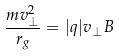Convert formula to latex. <formula><loc_0><loc_0><loc_500><loc_500>\frac { m v _ { \perp } ^ { 2 } } { r _ { g } } = | q | v _ { \perp } B</formula> 